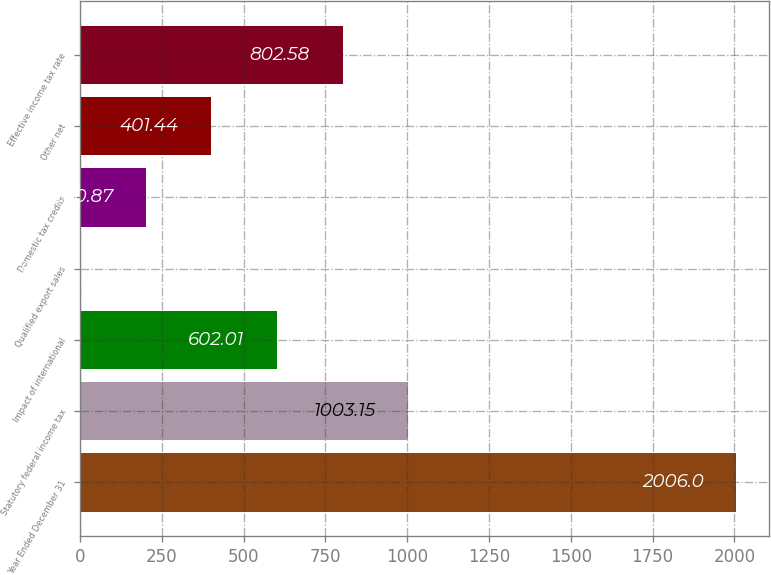Convert chart to OTSL. <chart><loc_0><loc_0><loc_500><loc_500><bar_chart><fcel>Year Ended December 31<fcel>Statutory federal income tax<fcel>Impact of international<fcel>Qualified export sales<fcel>Domestic tax credits<fcel>Other net<fcel>Effective income tax rate<nl><fcel>2006<fcel>1003.15<fcel>602.01<fcel>0.3<fcel>200.87<fcel>401.44<fcel>802.58<nl></chart> 